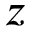<formula> <loc_0><loc_0><loc_500><loc_500>z</formula> 